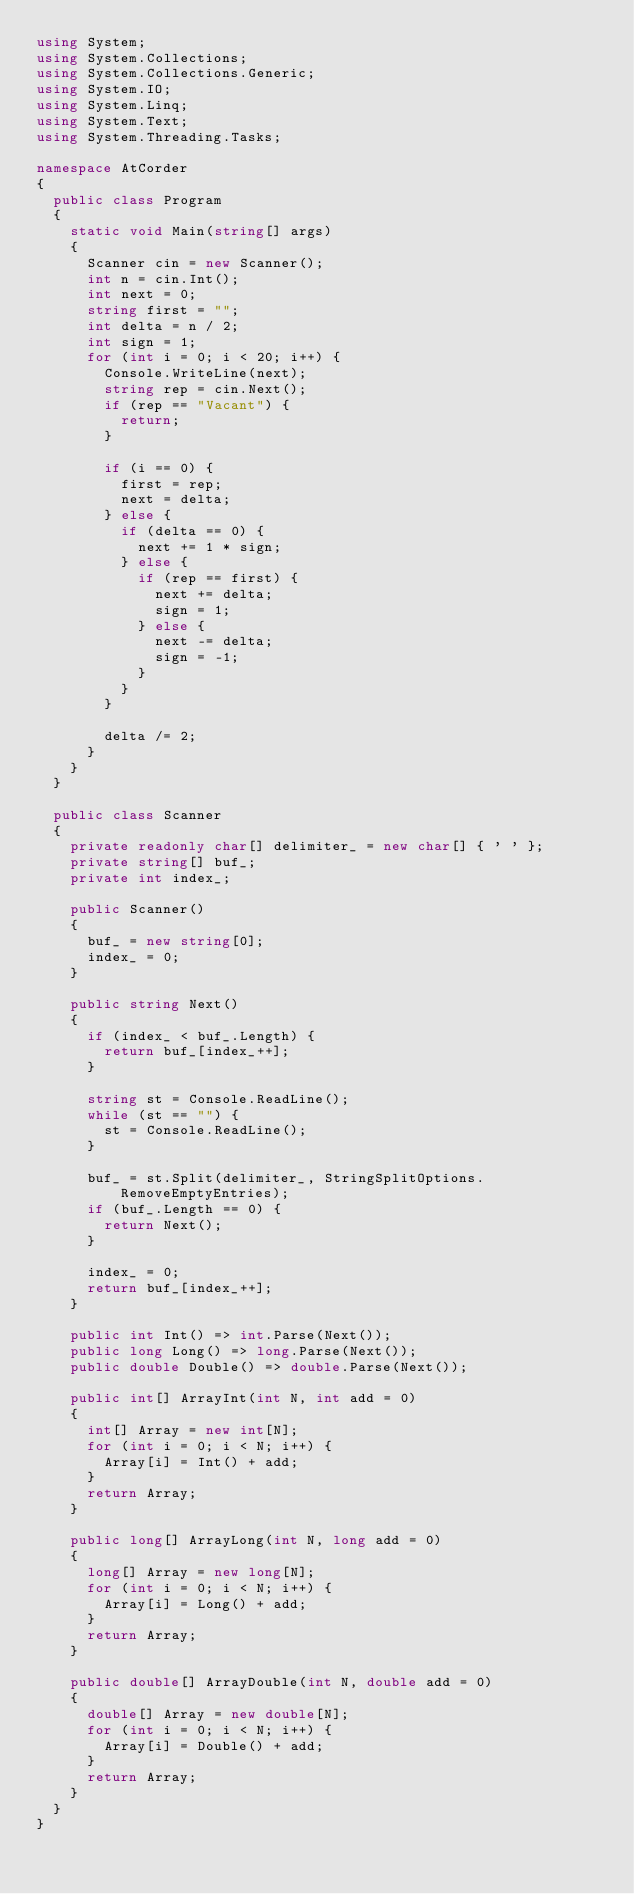Convert code to text. <code><loc_0><loc_0><loc_500><loc_500><_C#_>using System;
using System.Collections;
using System.Collections.Generic;
using System.IO;
using System.Linq;
using System.Text;
using System.Threading.Tasks;

namespace AtCorder
{
	public class Program
	{
		static void Main(string[] args)
		{
			Scanner cin = new Scanner();
			int n = cin.Int();
			int next = 0;
			string first = "";
			int delta = n / 2;
			int sign = 1;
			for (int i = 0; i < 20; i++) {
				Console.WriteLine(next);
				string rep = cin.Next();
				if (rep == "Vacant") {
					return;
				}

				if (i == 0) {
					first = rep;
					next = delta;
				} else {
					if (delta == 0) {
						next += 1 * sign;
					} else {
						if (rep == first) {
							next += delta;
							sign = 1;
						} else {
							next -= delta;
							sign = -1;
						}
					}
				}

				delta /= 2;
			}
		}
	}

	public class Scanner
	{
		private readonly char[] delimiter_ = new char[] { ' ' };
		private string[] buf_;
		private int index_;

		public Scanner()
		{
			buf_ = new string[0];
			index_ = 0;
		}

		public string Next()
		{
			if (index_ < buf_.Length) {
				return buf_[index_++];
			}

			string st = Console.ReadLine();
			while (st == "") {
				st = Console.ReadLine();
			}

			buf_ = st.Split(delimiter_, StringSplitOptions.RemoveEmptyEntries);
			if (buf_.Length == 0) {
				return Next();
			}

			index_ = 0;
			return buf_[index_++];
		}

		public int Int() => int.Parse(Next());
		public long Long() => long.Parse(Next());
		public double Double() => double.Parse(Next());

		public int[] ArrayInt(int N, int add = 0)
		{
			int[] Array = new int[N];
			for (int i = 0; i < N; i++) {
				Array[i] = Int() + add;
			}
			return Array;
		}

		public long[] ArrayLong(int N, long add = 0)
		{
			long[] Array = new long[N];
			for (int i = 0; i < N; i++) {
				Array[i] = Long() + add;
			}
			return Array;
		}

		public double[] ArrayDouble(int N, double add = 0)
		{
			double[] Array = new double[N];
			for (int i = 0; i < N; i++) {
				Array[i] = Double() + add;
			}
			return Array;
		}
	}
}</code> 